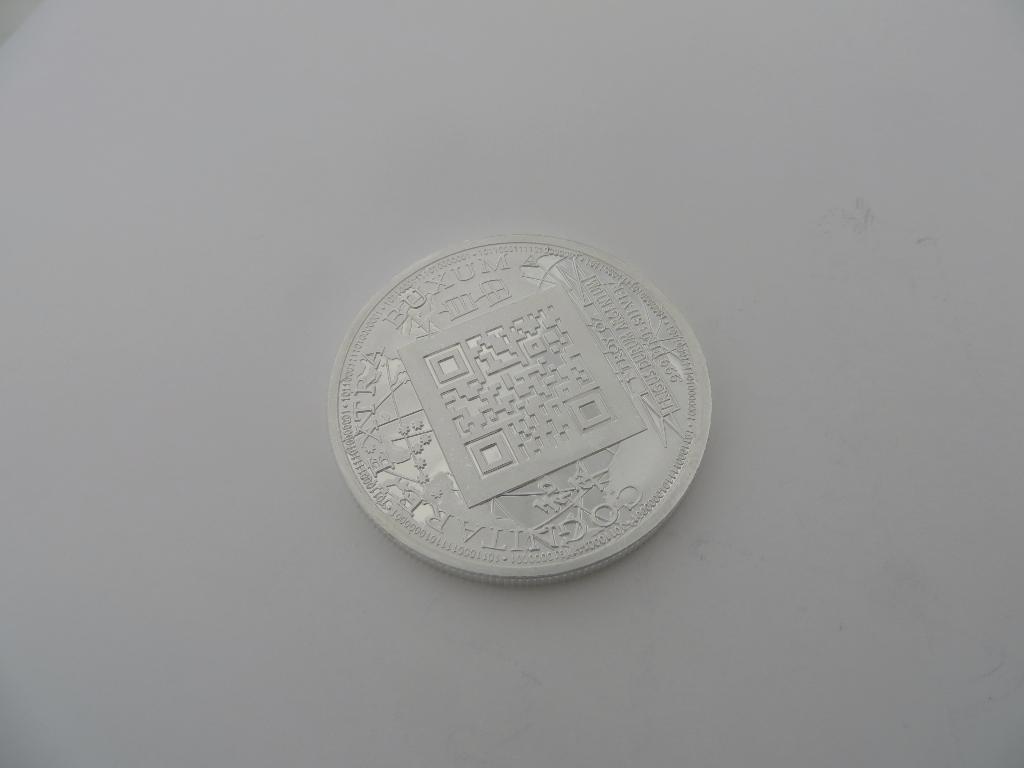Is that a coin?
Provide a succinct answer. Answering does not require reading text in the image. What text is displayed in the coin?
Your response must be concise. Unanswerable. 